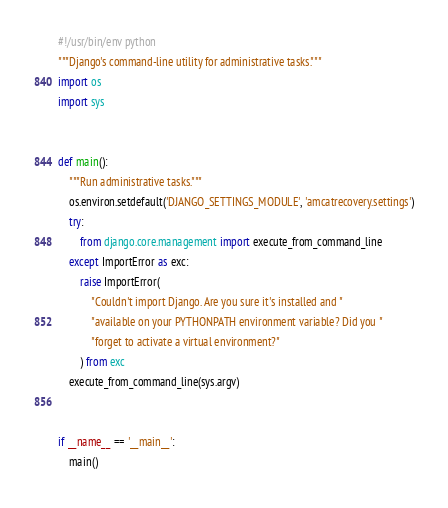<code> <loc_0><loc_0><loc_500><loc_500><_Python_>#!/usr/bin/env python
"""Django's command-line utility for administrative tasks."""
import os
import sys


def main():
    """Run administrative tasks."""
    os.environ.setdefault('DJANGO_SETTINGS_MODULE', 'amcatrecovery.settings')
    try:
        from django.core.management import execute_from_command_line
    except ImportError as exc:
        raise ImportError(
            "Couldn't import Django. Are you sure it's installed and "
            "available on your PYTHONPATH environment variable? Did you "
            "forget to activate a virtual environment?"
        ) from exc
    execute_from_command_line(sys.argv)


if __name__ == '__main__':
    main()
</code> 